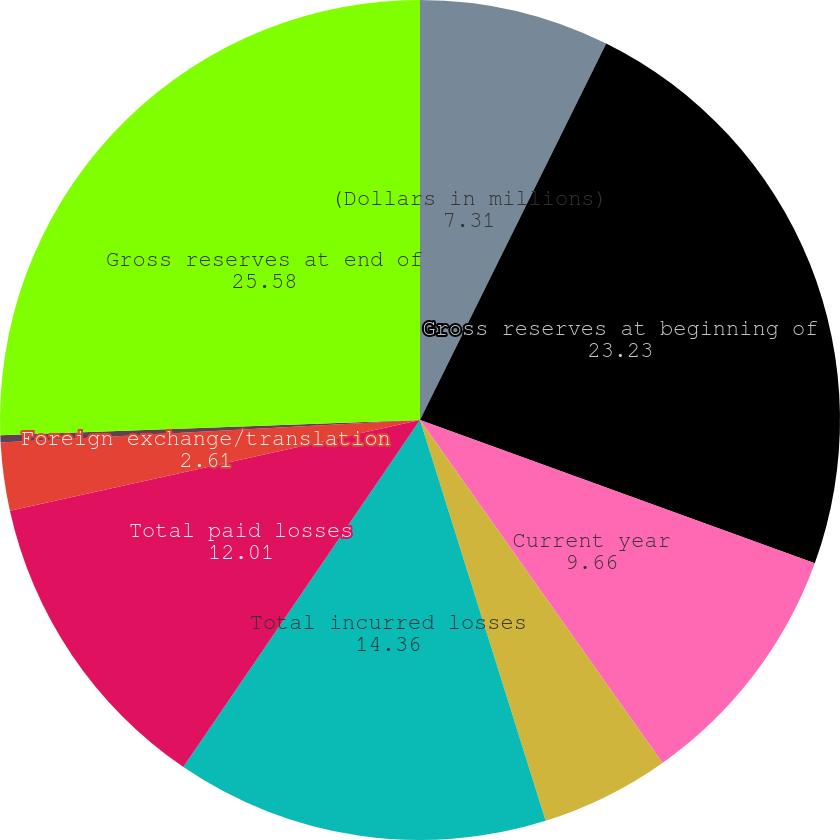<chart> <loc_0><loc_0><loc_500><loc_500><pie_chart><fcel>(Dollars in millions)<fcel>Gross reserves at beginning of<fcel>Current year<fcel>Prior years<fcel>Total incurred losses<fcel>Total paid losses<fcel>Foreign exchange/translation<fcel>Change in reinsurance<fcel>Gross reserves at end of<nl><fcel>7.31%<fcel>23.23%<fcel>9.66%<fcel>4.96%<fcel>14.36%<fcel>12.01%<fcel>2.61%<fcel>0.27%<fcel>25.58%<nl></chart> 